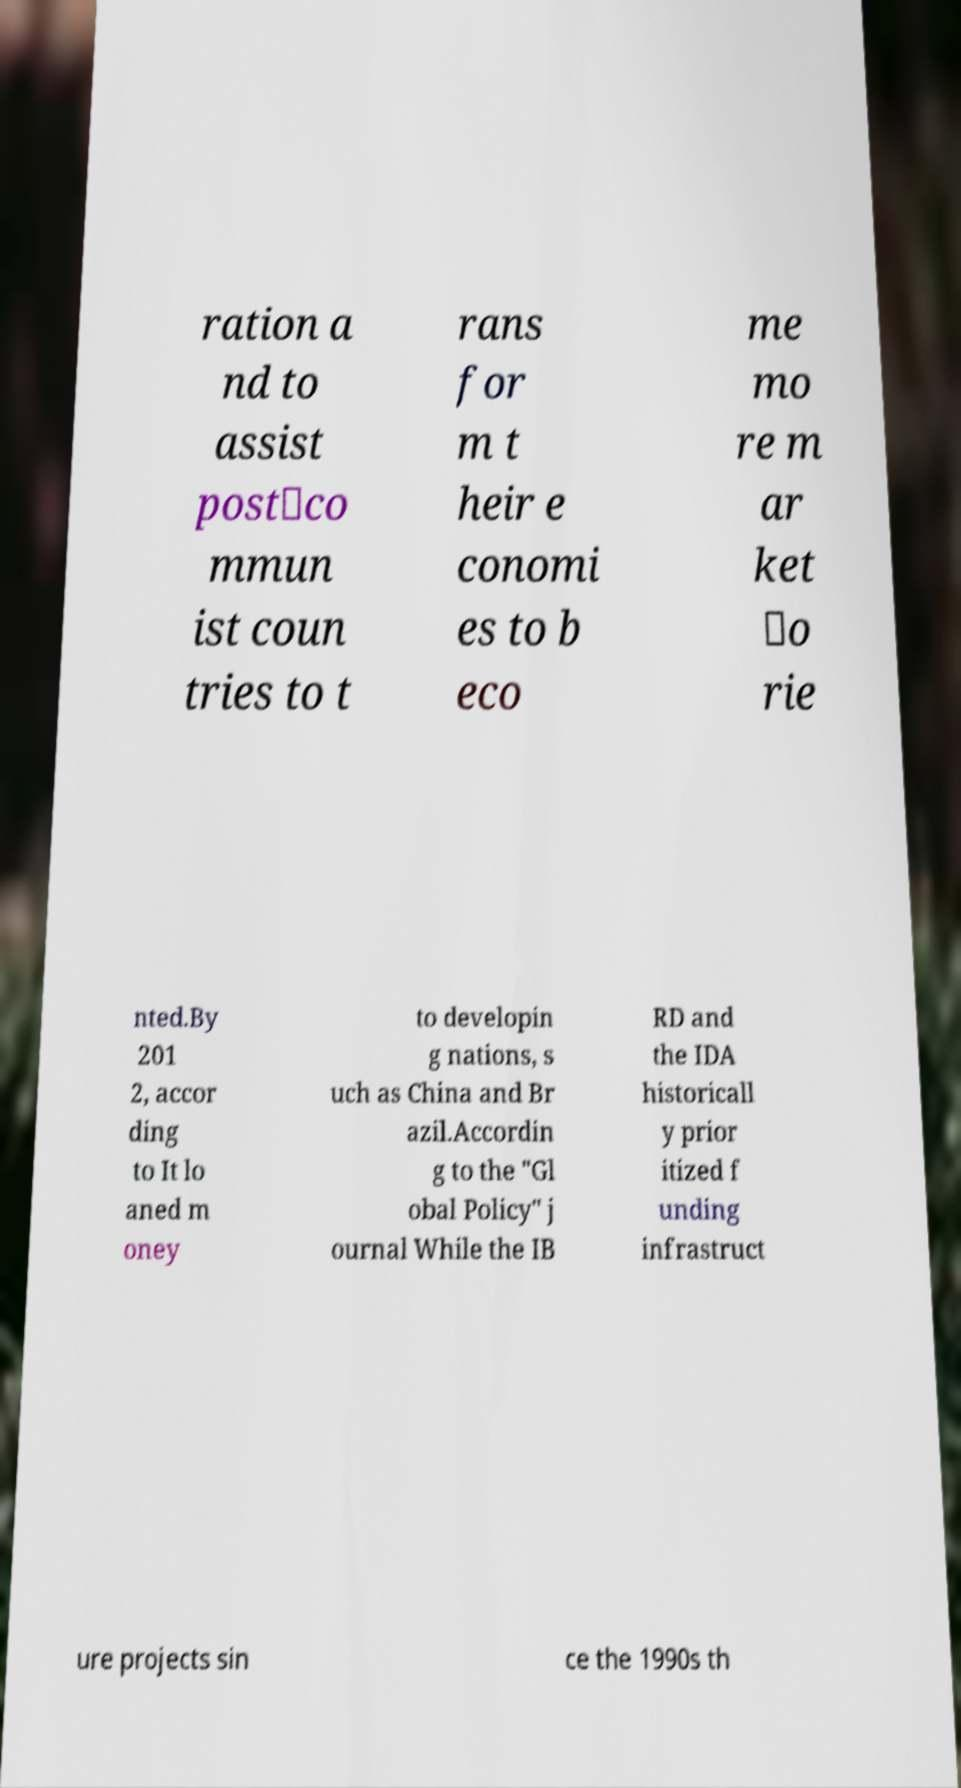I need the written content from this picture converted into text. Can you do that? ration a nd to assist post‐co mmun ist coun tries to t rans for m t heir e conomi es to b eco me mo re m ar ket ‐o rie nted.By 201 2, accor ding to It lo aned m oney to developin g nations, s uch as China and Br azil.Accordin g to the "Gl obal Policy" j ournal While the IB RD and the IDA historicall y prior itized f unding infrastruct ure projects sin ce the 1990s th 